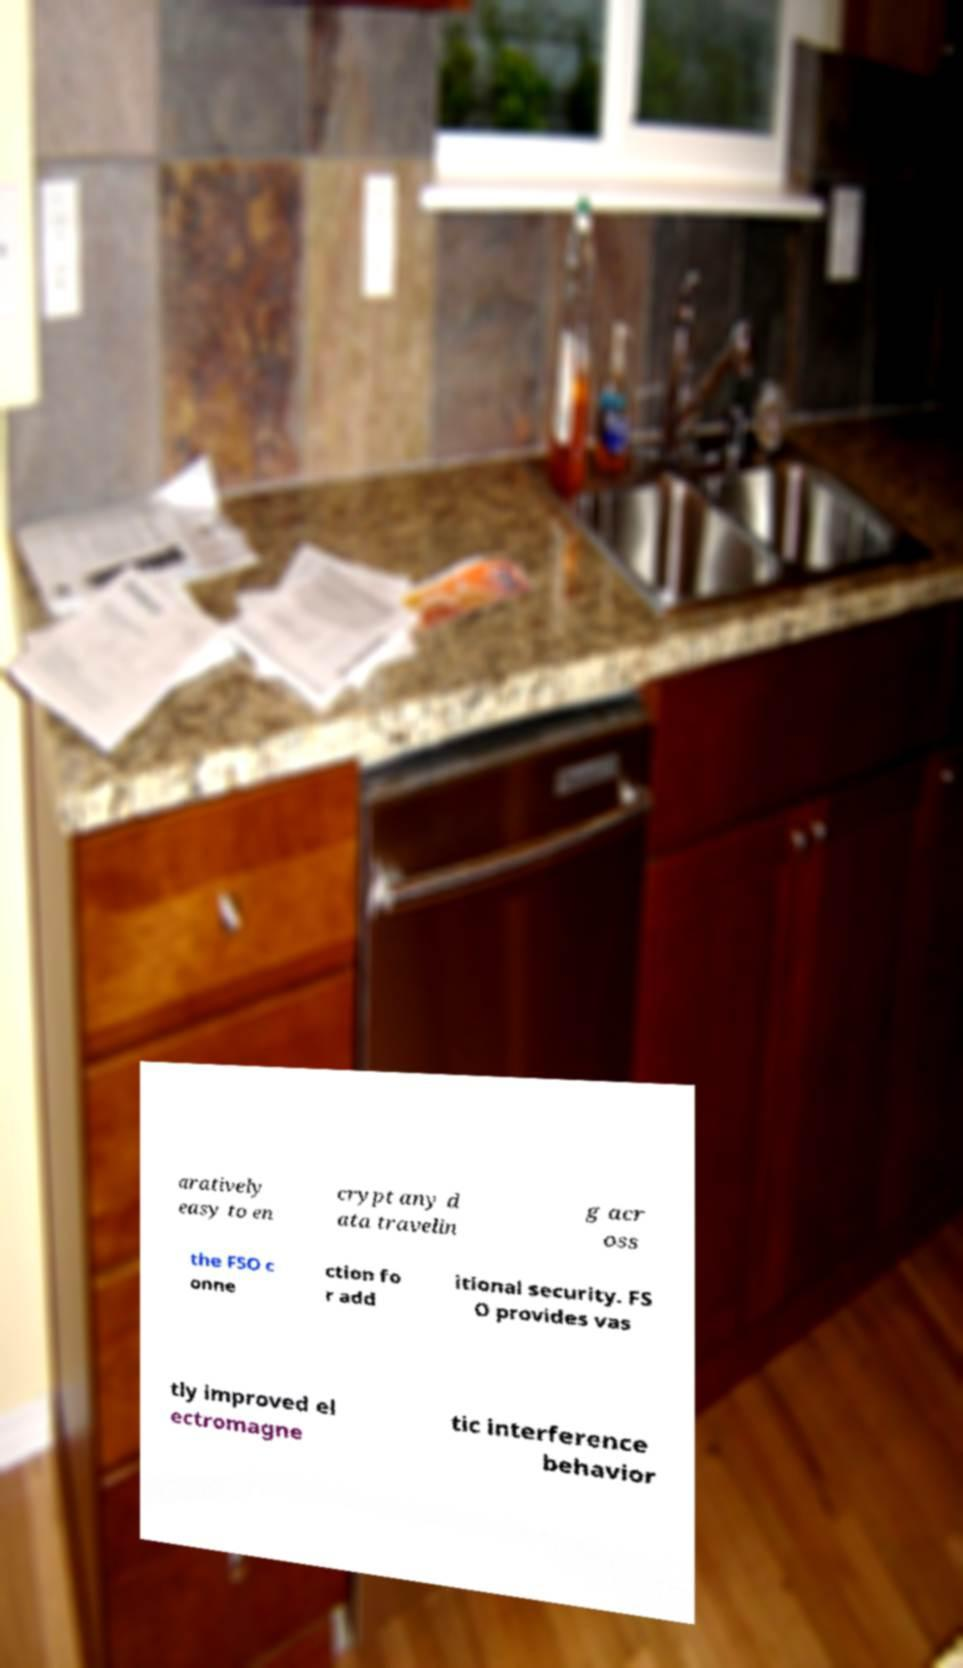I need the written content from this picture converted into text. Can you do that? aratively easy to en crypt any d ata travelin g acr oss the FSO c onne ction fo r add itional security. FS O provides vas tly improved el ectromagne tic interference behavior 